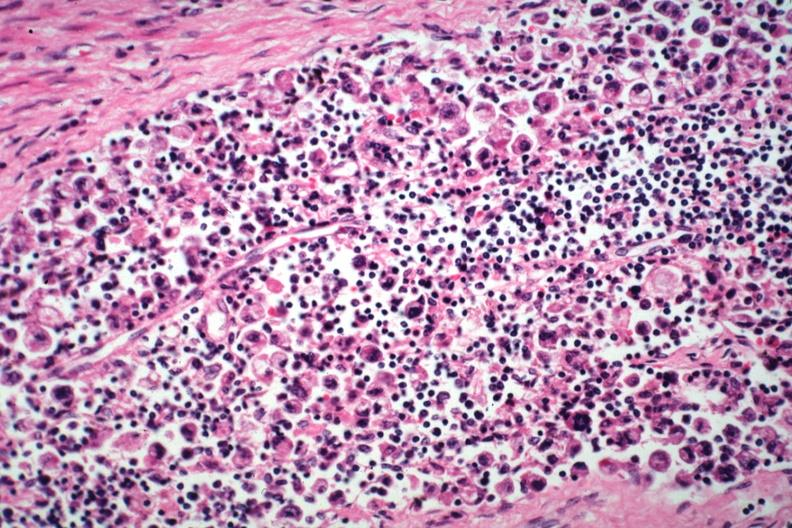what died with promyelocytic leukemia stomach lesion #?
Answer the question using a single word or phrase. Incidental finding 